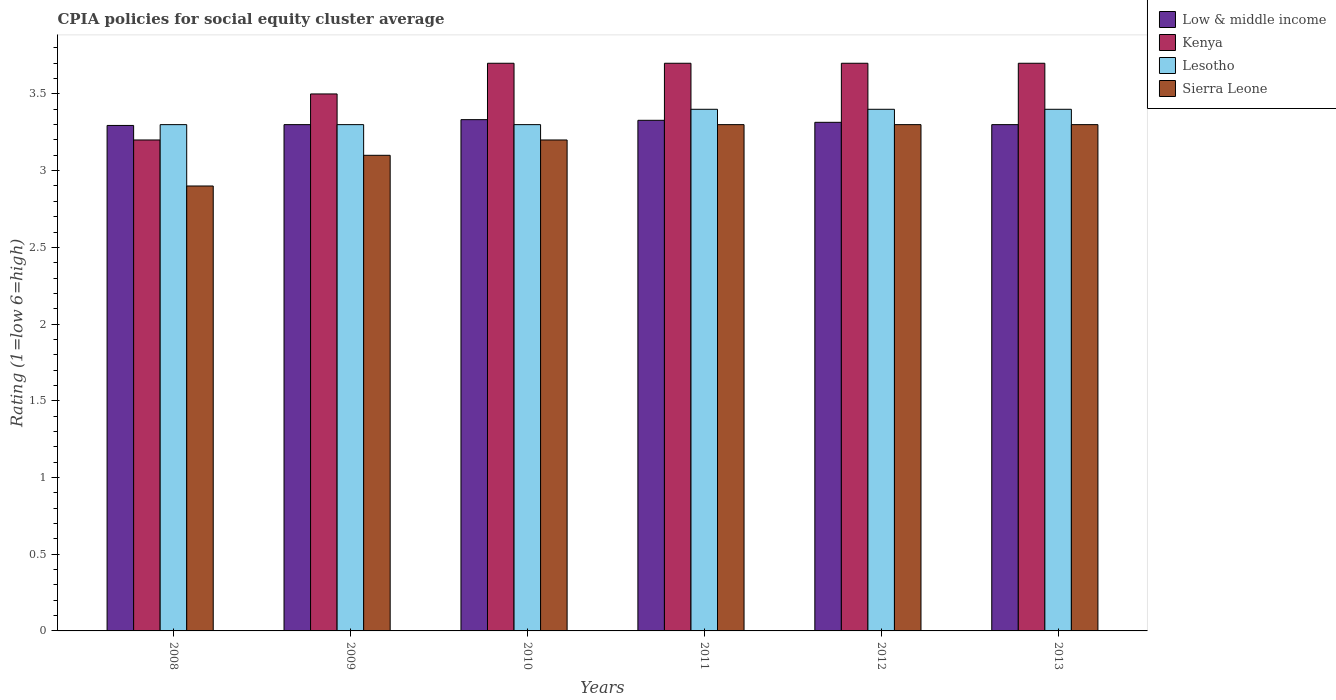How many different coloured bars are there?
Your answer should be compact. 4. How many groups of bars are there?
Offer a terse response. 6. Are the number of bars on each tick of the X-axis equal?
Provide a short and direct response. Yes. In how many cases, is the number of bars for a given year not equal to the number of legend labels?
Provide a succinct answer. 0. Across all years, what is the maximum CPIA rating in Lesotho?
Your answer should be very brief. 3.4. What is the total CPIA rating in Sierra Leone in the graph?
Your answer should be very brief. 19.1. What is the difference between the CPIA rating in Low & middle income in 2011 and that in 2012?
Offer a terse response. 0.01. What is the difference between the CPIA rating in Sierra Leone in 2009 and the CPIA rating in Kenya in 2013?
Your answer should be compact. -0.6. What is the average CPIA rating in Low & middle income per year?
Give a very brief answer. 3.31. In the year 2008, what is the difference between the CPIA rating in Lesotho and CPIA rating in Kenya?
Give a very brief answer. 0.1. What is the ratio of the CPIA rating in Sierra Leone in 2009 to that in 2011?
Your response must be concise. 0.94. Is the CPIA rating in Lesotho in 2011 less than that in 2013?
Offer a terse response. No. What is the difference between the highest and the second highest CPIA rating in Lesotho?
Your response must be concise. 0. What is the difference between the highest and the lowest CPIA rating in Low & middle income?
Give a very brief answer. 0.04. In how many years, is the CPIA rating in Sierra Leone greater than the average CPIA rating in Sierra Leone taken over all years?
Your answer should be very brief. 4. Is the sum of the CPIA rating in Low & middle income in 2009 and 2011 greater than the maximum CPIA rating in Kenya across all years?
Give a very brief answer. Yes. What does the 4th bar from the right in 2012 represents?
Give a very brief answer. Low & middle income. Is it the case that in every year, the sum of the CPIA rating in Kenya and CPIA rating in Low & middle income is greater than the CPIA rating in Lesotho?
Give a very brief answer. Yes. How many bars are there?
Give a very brief answer. 24. Are all the bars in the graph horizontal?
Your answer should be compact. No. Are the values on the major ticks of Y-axis written in scientific E-notation?
Your answer should be compact. No. Does the graph contain any zero values?
Ensure brevity in your answer.  No. Where does the legend appear in the graph?
Offer a very short reply. Top right. How many legend labels are there?
Keep it short and to the point. 4. How are the legend labels stacked?
Provide a succinct answer. Vertical. What is the title of the graph?
Keep it short and to the point. CPIA policies for social equity cluster average. Does "Serbia" appear as one of the legend labels in the graph?
Keep it short and to the point. No. What is the label or title of the X-axis?
Your answer should be very brief. Years. What is the Rating (1=low 6=high) of Low & middle income in 2008?
Give a very brief answer. 3.29. What is the Rating (1=low 6=high) in Kenya in 2008?
Provide a short and direct response. 3.2. What is the Rating (1=low 6=high) in Low & middle income in 2009?
Your response must be concise. 3.3. What is the Rating (1=low 6=high) in Sierra Leone in 2009?
Your answer should be compact. 3.1. What is the Rating (1=low 6=high) of Low & middle income in 2010?
Give a very brief answer. 3.33. What is the Rating (1=low 6=high) in Kenya in 2010?
Offer a terse response. 3.7. What is the Rating (1=low 6=high) of Lesotho in 2010?
Offer a very short reply. 3.3. What is the Rating (1=low 6=high) in Low & middle income in 2011?
Provide a succinct answer. 3.33. What is the Rating (1=low 6=high) in Kenya in 2011?
Give a very brief answer. 3.7. What is the Rating (1=low 6=high) in Low & middle income in 2012?
Offer a terse response. 3.31. What is the Rating (1=low 6=high) in Sierra Leone in 2012?
Keep it short and to the point. 3.3. What is the Rating (1=low 6=high) in Low & middle income in 2013?
Give a very brief answer. 3.3. What is the Rating (1=low 6=high) in Kenya in 2013?
Offer a very short reply. 3.7. Across all years, what is the maximum Rating (1=low 6=high) in Low & middle income?
Make the answer very short. 3.33. Across all years, what is the maximum Rating (1=low 6=high) of Kenya?
Give a very brief answer. 3.7. Across all years, what is the minimum Rating (1=low 6=high) of Low & middle income?
Your answer should be compact. 3.29. Across all years, what is the minimum Rating (1=low 6=high) of Kenya?
Give a very brief answer. 3.2. Across all years, what is the minimum Rating (1=low 6=high) of Lesotho?
Your answer should be compact. 3.3. Across all years, what is the minimum Rating (1=low 6=high) in Sierra Leone?
Offer a terse response. 2.9. What is the total Rating (1=low 6=high) in Low & middle income in the graph?
Offer a very short reply. 19.87. What is the total Rating (1=low 6=high) of Kenya in the graph?
Your answer should be compact. 21.5. What is the total Rating (1=low 6=high) in Lesotho in the graph?
Your answer should be very brief. 20.1. What is the total Rating (1=low 6=high) of Sierra Leone in the graph?
Provide a short and direct response. 19.1. What is the difference between the Rating (1=low 6=high) of Low & middle income in 2008 and that in 2009?
Ensure brevity in your answer.  -0.01. What is the difference between the Rating (1=low 6=high) of Low & middle income in 2008 and that in 2010?
Ensure brevity in your answer.  -0.04. What is the difference between the Rating (1=low 6=high) of Lesotho in 2008 and that in 2010?
Make the answer very short. 0. What is the difference between the Rating (1=low 6=high) of Low & middle income in 2008 and that in 2011?
Your response must be concise. -0.03. What is the difference between the Rating (1=low 6=high) in Lesotho in 2008 and that in 2011?
Your answer should be very brief. -0.1. What is the difference between the Rating (1=low 6=high) of Low & middle income in 2008 and that in 2012?
Ensure brevity in your answer.  -0.02. What is the difference between the Rating (1=low 6=high) of Low & middle income in 2008 and that in 2013?
Provide a short and direct response. -0.01. What is the difference between the Rating (1=low 6=high) of Kenya in 2008 and that in 2013?
Provide a short and direct response. -0.5. What is the difference between the Rating (1=low 6=high) of Low & middle income in 2009 and that in 2010?
Your answer should be very brief. -0.03. What is the difference between the Rating (1=low 6=high) of Low & middle income in 2009 and that in 2011?
Provide a short and direct response. -0.03. What is the difference between the Rating (1=low 6=high) of Kenya in 2009 and that in 2011?
Provide a short and direct response. -0.2. What is the difference between the Rating (1=low 6=high) in Lesotho in 2009 and that in 2011?
Make the answer very short. -0.1. What is the difference between the Rating (1=low 6=high) in Sierra Leone in 2009 and that in 2011?
Keep it short and to the point. -0.2. What is the difference between the Rating (1=low 6=high) in Low & middle income in 2009 and that in 2012?
Keep it short and to the point. -0.01. What is the difference between the Rating (1=low 6=high) in Kenya in 2009 and that in 2012?
Your answer should be compact. -0.2. What is the difference between the Rating (1=low 6=high) of Low & middle income in 2009 and that in 2013?
Keep it short and to the point. 0. What is the difference between the Rating (1=low 6=high) of Kenya in 2009 and that in 2013?
Provide a short and direct response. -0.2. What is the difference between the Rating (1=low 6=high) of Low & middle income in 2010 and that in 2011?
Ensure brevity in your answer.  0. What is the difference between the Rating (1=low 6=high) in Lesotho in 2010 and that in 2011?
Provide a short and direct response. -0.1. What is the difference between the Rating (1=low 6=high) of Low & middle income in 2010 and that in 2012?
Provide a succinct answer. 0.02. What is the difference between the Rating (1=low 6=high) of Kenya in 2010 and that in 2012?
Give a very brief answer. 0. What is the difference between the Rating (1=low 6=high) in Lesotho in 2010 and that in 2012?
Provide a short and direct response. -0.1. What is the difference between the Rating (1=low 6=high) in Sierra Leone in 2010 and that in 2012?
Provide a succinct answer. -0.1. What is the difference between the Rating (1=low 6=high) in Low & middle income in 2010 and that in 2013?
Provide a short and direct response. 0.03. What is the difference between the Rating (1=low 6=high) in Kenya in 2010 and that in 2013?
Your answer should be very brief. 0. What is the difference between the Rating (1=low 6=high) in Sierra Leone in 2010 and that in 2013?
Offer a very short reply. -0.1. What is the difference between the Rating (1=low 6=high) of Low & middle income in 2011 and that in 2012?
Your answer should be very brief. 0.01. What is the difference between the Rating (1=low 6=high) of Sierra Leone in 2011 and that in 2012?
Your answer should be compact. 0. What is the difference between the Rating (1=low 6=high) of Low & middle income in 2011 and that in 2013?
Provide a succinct answer. 0.03. What is the difference between the Rating (1=low 6=high) of Kenya in 2011 and that in 2013?
Offer a very short reply. 0. What is the difference between the Rating (1=low 6=high) of Low & middle income in 2012 and that in 2013?
Your response must be concise. 0.01. What is the difference between the Rating (1=low 6=high) in Kenya in 2012 and that in 2013?
Give a very brief answer. 0. What is the difference between the Rating (1=low 6=high) of Lesotho in 2012 and that in 2013?
Your answer should be compact. 0. What is the difference between the Rating (1=low 6=high) in Sierra Leone in 2012 and that in 2013?
Keep it short and to the point. 0. What is the difference between the Rating (1=low 6=high) in Low & middle income in 2008 and the Rating (1=low 6=high) in Kenya in 2009?
Make the answer very short. -0.21. What is the difference between the Rating (1=low 6=high) in Low & middle income in 2008 and the Rating (1=low 6=high) in Lesotho in 2009?
Your answer should be compact. -0.01. What is the difference between the Rating (1=low 6=high) of Low & middle income in 2008 and the Rating (1=low 6=high) of Sierra Leone in 2009?
Keep it short and to the point. 0.19. What is the difference between the Rating (1=low 6=high) of Lesotho in 2008 and the Rating (1=low 6=high) of Sierra Leone in 2009?
Give a very brief answer. 0.2. What is the difference between the Rating (1=low 6=high) in Low & middle income in 2008 and the Rating (1=low 6=high) in Kenya in 2010?
Give a very brief answer. -0.41. What is the difference between the Rating (1=low 6=high) in Low & middle income in 2008 and the Rating (1=low 6=high) in Lesotho in 2010?
Your answer should be very brief. -0.01. What is the difference between the Rating (1=low 6=high) in Low & middle income in 2008 and the Rating (1=low 6=high) in Sierra Leone in 2010?
Your answer should be very brief. 0.09. What is the difference between the Rating (1=low 6=high) in Low & middle income in 2008 and the Rating (1=low 6=high) in Kenya in 2011?
Provide a succinct answer. -0.41. What is the difference between the Rating (1=low 6=high) of Low & middle income in 2008 and the Rating (1=low 6=high) of Lesotho in 2011?
Keep it short and to the point. -0.11. What is the difference between the Rating (1=low 6=high) in Low & middle income in 2008 and the Rating (1=low 6=high) in Sierra Leone in 2011?
Give a very brief answer. -0.01. What is the difference between the Rating (1=low 6=high) of Low & middle income in 2008 and the Rating (1=low 6=high) of Kenya in 2012?
Give a very brief answer. -0.41. What is the difference between the Rating (1=low 6=high) in Low & middle income in 2008 and the Rating (1=low 6=high) in Lesotho in 2012?
Ensure brevity in your answer.  -0.11. What is the difference between the Rating (1=low 6=high) in Low & middle income in 2008 and the Rating (1=low 6=high) in Sierra Leone in 2012?
Offer a terse response. -0.01. What is the difference between the Rating (1=low 6=high) in Kenya in 2008 and the Rating (1=low 6=high) in Lesotho in 2012?
Offer a very short reply. -0.2. What is the difference between the Rating (1=low 6=high) in Low & middle income in 2008 and the Rating (1=low 6=high) in Kenya in 2013?
Your answer should be very brief. -0.41. What is the difference between the Rating (1=low 6=high) in Low & middle income in 2008 and the Rating (1=low 6=high) in Lesotho in 2013?
Provide a short and direct response. -0.11. What is the difference between the Rating (1=low 6=high) in Low & middle income in 2008 and the Rating (1=low 6=high) in Sierra Leone in 2013?
Keep it short and to the point. -0.01. What is the difference between the Rating (1=low 6=high) of Kenya in 2008 and the Rating (1=low 6=high) of Lesotho in 2013?
Provide a succinct answer. -0.2. What is the difference between the Rating (1=low 6=high) of Low & middle income in 2009 and the Rating (1=low 6=high) of Kenya in 2010?
Give a very brief answer. -0.4. What is the difference between the Rating (1=low 6=high) of Low & middle income in 2009 and the Rating (1=low 6=high) of Sierra Leone in 2010?
Offer a very short reply. 0.1. What is the difference between the Rating (1=low 6=high) in Kenya in 2009 and the Rating (1=low 6=high) in Sierra Leone in 2010?
Your answer should be compact. 0.3. What is the difference between the Rating (1=low 6=high) in Low & middle income in 2009 and the Rating (1=low 6=high) in Lesotho in 2011?
Give a very brief answer. -0.1. What is the difference between the Rating (1=low 6=high) of Low & middle income in 2009 and the Rating (1=low 6=high) of Sierra Leone in 2011?
Offer a very short reply. 0. What is the difference between the Rating (1=low 6=high) in Kenya in 2009 and the Rating (1=low 6=high) in Lesotho in 2011?
Offer a very short reply. 0.1. What is the difference between the Rating (1=low 6=high) in Lesotho in 2009 and the Rating (1=low 6=high) in Sierra Leone in 2011?
Make the answer very short. 0. What is the difference between the Rating (1=low 6=high) in Low & middle income in 2009 and the Rating (1=low 6=high) in Kenya in 2012?
Provide a short and direct response. -0.4. What is the difference between the Rating (1=low 6=high) of Kenya in 2009 and the Rating (1=low 6=high) of Lesotho in 2012?
Provide a succinct answer. 0.1. What is the difference between the Rating (1=low 6=high) of Lesotho in 2009 and the Rating (1=low 6=high) of Sierra Leone in 2012?
Your answer should be very brief. 0. What is the difference between the Rating (1=low 6=high) in Low & middle income in 2009 and the Rating (1=low 6=high) in Kenya in 2013?
Offer a very short reply. -0.4. What is the difference between the Rating (1=low 6=high) of Low & middle income in 2009 and the Rating (1=low 6=high) of Sierra Leone in 2013?
Offer a terse response. 0. What is the difference between the Rating (1=low 6=high) of Kenya in 2009 and the Rating (1=low 6=high) of Sierra Leone in 2013?
Give a very brief answer. 0.2. What is the difference between the Rating (1=low 6=high) in Low & middle income in 2010 and the Rating (1=low 6=high) in Kenya in 2011?
Make the answer very short. -0.37. What is the difference between the Rating (1=low 6=high) in Low & middle income in 2010 and the Rating (1=low 6=high) in Lesotho in 2011?
Your answer should be very brief. -0.07. What is the difference between the Rating (1=low 6=high) of Low & middle income in 2010 and the Rating (1=low 6=high) of Sierra Leone in 2011?
Keep it short and to the point. 0.03. What is the difference between the Rating (1=low 6=high) in Kenya in 2010 and the Rating (1=low 6=high) in Lesotho in 2011?
Your answer should be very brief. 0.3. What is the difference between the Rating (1=low 6=high) of Kenya in 2010 and the Rating (1=low 6=high) of Sierra Leone in 2011?
Your answer should be compact. 0.4. What is the difference between the Rating (1=low 6=high) of Lesotho in 2010 and the Rating (1=low 6=high) of Sierra Leone in 2011?
Your answer should be very brief. 0. What is the difference between the Rating (1=low 6=high) in Low & middle income in 2010 and the Rating (1=low 6=high) in Kenya in 2012?
Keep it short and to the point. -0.37. What is the difference between the Rating (1=low 6=high) in Low & middle income in 2010 and the Rating (1=low 6=high) in Lesotho in 2012?
Your answer should be compact. -0.07. What is the difference between the Rating (1=low 6=high) in Low & middle income in 2010 and the Rating (1=low 6=high) in Sierra Leone in 2012?
Give a very brief answer. 0.03. What is the difference between the Rating (1=low 6=high) of Kenya in 2010 and the Rating (1=low 6=high) of Sierra Leone in 2012?
Your response must be concise. 0.4. What is the difference between the Rating (1=low 6=high) in Lesotho in 2010 and the Rating (1=low 6=high) in Sierra Leone in 2012?
Your response must be concise. 0. What is the difference between the Rating (1=low 6=high) in Low & middle income in 2010 and the Rating (1=low 6=high) in Kenya in 2013?
Make the answer very short. -0.37. What is the difference between the Rating (1=low 6=high) of Low & middle income in 2010 and the Rating (1=low 6=high) of Lesotho in 2013?
Give a very brief answer. -0.07. What is the difference between the Rating (1=low 6=high) of Low & middle income in 2010 and the Rating (1=low 6=high) of Sierra Leone in 2013?
Your answer should be very brief. 0.03. What is the difference between the Rating (1=low 6=high) of Kenya in 2010 and the Rating (1=low 6=high) of Sierra Leone in 2013?
Your response must be concise. 0.4. What is the difference between the Rating (1=low 6=high) of Lesotho in 2010 and the Rating (1=low 6=high) of Sierra Leone in 2013?
Offer a terse response. 0. What is the difference between the Rating (1=low 6=high) of Low & middle income in 2011 and the Rating (1=low 6=high) of Kenya in 2012?
Your response must be concise. -0.37. What is the difference between the Rating (1=low 6=high) in Low & middle income in 2011 and the Rating (1=low 6=high) in Lesotho in 2012?
Your answer should be compact. -0.07. What is the difference between the Rating (1=low 6=high) of Low & middle income in 2011 and the Rating (1=low 6=high) of Sierra Leone in 2012?
Your response must be concise. 0.03. What is the difference between the Rating (1=low 6=high) in Low & middle income in 2011 and the Rating (1=low 6=high) in Kenya in 2013?
Ensure brevity in your answer.  -0.37. What is the difference between the Rating (1=low 6=high) of Low & middle income in 2011 and the Rating (1=low 6=high) of Lesotho in 2013?
Provide a short and direct response. -0.07. What is the difference between the Rating (1=low 6=high) in Low & middle income in 2011 and the Rating (1=low 6=high) in Sierra Leone in 2013?
Keep it short and to the point. 0.03. What is the difference between the Rating (1=low 6=high) in Kenya in 2011 and the Rating (1=low 6=high) in Sierra Leone in 2013?
Your answer should be very brief. 0.4. What is the difference between the Rating (1=low 6=high) of Low & middle income in 2012 and the Rating (1=low 6=high) of Kenya in 2013?
Make the answer very short. -0.39. What is the difference between the Rating (1=low 6=high) in Low & middle income in 2012 and the Rating (1=low 6=high) in Lesotho in 2013?
Keep it short and to the point. -0.09. What is the difference between the Rating (1=low 6=high) in Low & middle income in 2012 and the Rating (1=low 6=high) in Sierra Leone in 2013?
Your answer should be very brief. 0.01. What is the difference between the Rating (1=low 6=high) of Kenya in 2012 and the Rating (1=low 6=high) of Sierra Leone in 2013?
Your response must be concise. 0.4. What is the difference between the Rating (1=low 6=high) in Lesotho in 2012 and the Rating (1=low 6=high) in Sierra Leone in 2013?
Give a very brief answer. 0.1. What is the average Rating (1=low 6=high) of Low & middle income per year?
Your answer should be compact. 3.31. What is the average Rating (1=low 6=high) of Kenya per year?
Provide a short and direct response. 3.58. What is the average Rating (1=low 6=high) in Lesotho per year?
Offer a very short reply. 3.35. What is the average Rating (1=low 6=high) of Sierra Leone per year?
Your answer should be very brief. 3.18. In the year 2008, what is the difference between the Rating (1=low 6=high) of Low & middle income and Rating (1=low 6=high) of Kenya?
Your answer should be compact. 0.09. In the year 2008, what is the difference between the Rating (1=low 6=high) of Low & middle income and Rating (1=low 6=high) of Lesotho?
Make the answer very short. -0.01. In the year 2008, what is the difference between the Rating (1=low 6=high) of Low & middle income and Rating (1=low 6=high) of Sierra Leone?
Your response must be concise. 0.39. In the year 2008, what is the difference between the Rating (1=low 6=high) of Kenya and Rating (1=low 6=high) of Sierra Leone?
Offer a terse response. 0.3. In the year 2009, what is the difference between the Rating (1=low 6=high) of Low & middle income and Rating (1=low 6=high) of Kenya?
Provide a succinct answer. -0.2. In the year 2009, what is the difference between the Rating (1=low 6=high) of Low & middle income and Rating (1=low 6=high) of Lesotho?
Ensure brevity in your answer.  0. In the year 2009, what is the difference between the Rating (1=low 6=high) in Low & middle income and Rating (1=low 6=high) in Sierra Leone?
Your answer should be very brief. 0.2. In the year 2009, what is the difference between the Rating (1=low 6=high) in Kenya and Rating (1=low 6=high) in Lesotho?
Provide a short and direct response. 0.2. In the year 2009, what is the difference between the Rating (1=low 6=high) in Kenya and Rating (1=low 6=high) in Sierra Leone?
Provide a succinct answer. 0.4. In the year 2009, what is the difference between the Rating (1=low 6=high) of Lesotho and Rating (1=low 6=high) of Sierra Leone?
Keep it short and to the point. 0.2. In the year 2010, what is the difference between the Rating (1=low 6=high) of Low & middle income and Rating (1=low 6=high) of Kenya?
Ensure brevity in your answer.  -0.37. In the year 2010, what is the difference between the Rating (1=low 6=high) of Low & middle income and Rating (1=low 6=high) of Lesotho?
Give a very brief answer. 0.03. In the year 2010, what is the difference between the Rating (1=low 6=high) in Low & middle income and Rating (1=low 6=high) in Sierra Leone?
Provide a succinct answer. 0.13. In the year 2010, what is the difference between the Rating (1=low 6=high) of Kenya and Rating (1=low 6=high) of Lesotho?
Provide a short and direct response. 0.4. In the year 2011, what is the difference between the Rating (1=low 6=high) of Low & middle income and Rating (1=low 6=high) of Kenya?
Provide a short and direct response. -0.37. In the year 2011, what is the difference between the Rating (1=low 6=high) in Low & middle income and Rating (1=low 6=high) in Lesotho?
Ensure brevity in your answer.  -0.07. In the year 2011, what is the difference between the Rating (1=low 6=high) of Low & middle income and Rating (1=low 6=high) of Sierra Leone?
Offer a very short reply. 0.03. In the year 2012, what is the difference between the Rating (1=low 6=high) of Low & middle income and Rating (1=low 6=high) of Kenya?
Make the answer very short. -0.39. In the year 2012, what is the difference between the Rating (1=low 6=high) in Low & middle income and Rating (1=low 6=high) in Lesotho?
Give a very brief answer. -0.09. In the year 2012, what is the difference between the Rating (1=low 6=high) in Low & middle income and Rating (1=low 6=high) in Sierra Leone?
Keep it short and to the point. 0.01. In the year 2012, what is the difference between the Rating (1=low 6=high) of Lesotho and Rating (1=low 6=high) of Sierra Leone?
Your response must be concise. 0.1. In the year 2013, what is the difference between the Rating (1=low 6=high) in Low & middle income and Rating (1=low 6=high) in Lesotho?
Offer a terse response. -0.1. In the year 2013, what is the difference between the Rating (1=low 6=high) in Kenya and Rating (1=low 6=high) in Lesotho?
Provide a short and direct response. 0.3. What is the ratio of the Rating (1=low 6=high) of Low & middle income in 2008 to that in 2009?
Your answer should be compact. 1. What is the ratio of the Rating (1=low 6=high) in Kenya in 2008 to that in 2009?
Ensure brevity in your answer.  0.91. What is the ratio of the Rating (1=low 6=high) in Sierra Leone in 2008 to that in 2009?
Ensure brevity in your answer.  0.94. What is the ratio of the Rating (1=low 6=high) in Low & middle income in 2008 to that in 2010?
Keep it short and to the point. 0.99. What is the ratio of the Rating (1=low 6=high) in Kenya in 2008 to that in 2010?
Offer a terse response. 0.86. What is the ratio of the Rating (1=low 6=high) of Sierra Leone in 2008 to that in 2010?
Your answer should be compact. 0.91. What is the ratio of the Rating (1=low 6=high) of Kenya in 2008 to that in 2011?
Provide a succinct answer. 0.86. What is the ratio of the Rating (1=low 6=high) in Lesotho in 2008 to that in 2011?
Offer a terse response. 0.97. What is the ratio of the Rating (1=low 6=high) in Sierra Leone in 2008 to that in 2011?
Your response must be concise. 0.88. What is the ratio of the Rating (1=low 6=high) of Low & middle income in 2008 to that in 2012?
Make the answer very short. 0.99. What is the ratio of the Rating (1=low 6=high) of Kenya in 2008 to that in 2012?
Offer a terse response. 0.86. What is the ratio of the Rating (1=low 6=high) of Lesotho in 2008 to that in 2012?
Your response must be concise. 0.97. What is the ratio of the Rating (1=low 6=high) in Sierra Leone in 2008 to that in 2012?
Keep it short and to the point. 0.88. What is the ratio of the Rating (1=low 6=high) in Kenya in 2008 to that in 2013?
Ensure brevity in your answer.  0.86. What is the ratio of the Rating (1=low 6=high) in Lesotho in 2008 to that in 2013?
Provide a short and direct response. 0.97. What is the ratio of the Rating (1=low 6=high) in Sierra Leone in 2008 to that in 2013?
Your answer should be very brief. 0.88. What is the ratio of the Rating (1=low 6=high) in Low & middle income in 2009 to that in 2010?
Your response must be concise. 0.99. What is the ratio of the Rating (1=low 6=high) of Kenya in 2009 to that in 2010?
Your response must be concise. 0.95. What is the ratio of the Rating (1=low 6=high) in Sierra Leone in 2009 to that in 2010?
Offer a terse response. 0.97. What is the ratio of the Rating (1=low 6=high) of Low & middle income in 2009 to that in 2011?
Provide a succinct answer. 0.99. What is the ratio of the Rating (1=low 6=high) of Kenya in 2009 to that in 2011?
Give a very brief answer. 0.95. What is the ratio of the Rating (1=low 6=high) of Lesotho in 2009 to that in 2011?
Keep it short and to the point. 0.97. What is the ratio of the Rating (1=low 6=high) in Sierra Leone in 2009 to that in 2011?
Your answer should be compact. 0.94. What is the ratio of the Rating (1=low 6=high) in Low & middle income in 2009 to that in 2012?
Ensure brevity in your answer.  1. What is the ratio of the Rating (1=low 6=high) in Kenya in 2009 to that in 2012?
Your response must be concise. 0.95. What is the ratio of the Rating (1=low 6=high) of Lesotho in 2009 to that in 2012?
Ensure brevity in your answer.  0.97. What is the ratio of the Rating (1=low 6=high) in Sierra Leone in 2009 to that in 2012?
Make the answer very short. 0.94. What is the ratio of the Rating (1=low 6=high) in Kenya in 2009 to that in 2013?
Make the answer very short. 0.95. What is the ratio of the Rating (1=low 6=high) of Lesotho in 2009 to that in 2013?
Ensure brevity in your answer.  0.97. What is the ratio of the Rating (1=low 6=high) of Sierra Leone in 2009 to that in 2013?
Your answer should be compact. 0.94. What is the ratio of the Rating (1=low 6=high) in Lesotho in 2010 to that in 2011?
Your answer should be compact. 0.97. What is the ratio of the Rating (1=low 6=high) in Sierra Leone in 2010 to that in 2011?
Make the answer very short. 0.97. What is the ratio of the Rating (1=low 6=high) of Low & middle income in 2010 to that in 2012?
Your answer should be very brief. 1.01. What is the ratio of the Rating (1=low 6=high) of Lesotho in 2010 to that in 2012?
Your answer should be very brief. 0.97. What is the ratio of the Rating (1=low 6=high) of Sierra Leone in 2010 to that in 2012?
Give a very brief answer. 0.97. What is the ratio of the Rating (1=low 6=high) of Low & middle income in 2010 to that in 2013?
Provide a succinct answer. 1.01. What is the ratio of the Rating (1=low 6=high) in Kenya in 2010 to that in 2013?
Keep it short and to the point. 1. What is the ratio of the Rating (1=low 6=high) of Lesotho in 2010 to that in 2013?
Make the answer very short. 0.97. What is the ratio of the Rating (1=low 6=high) of Sierra Leone in 2010 to that in 2013?
Ensure brevity in your answer.  0.97. What is the ratio of the Rating (1=low 6=high) of Low & middle income in 2011 to that in 2012?
Make the answer very short. 1. What is the ratio of the Rating (1=low 6=high) in Kenya in 2011 to that in 2012?
Your answer should be very brief. 1. What is the ratio of the Rating (1=low 6=high) of Lesotho in 2011 to that in 2012?
Offer a terse response. 1. What is the ratio of the Rating (1=low 6=high) in Sierra Leone in 2011 to that in 2012?
Your answer should be very brief. 1. What is the ratio of the Rating (1=low 6=high) in Low & middle income in 2011 to that in 2013?
Give a very brief answer. 1.01. What is the ratio of the Rating (1=low 6=high) of Kenya in 2011 to that in 2013?
Provide a succinct answer. 1. What is the ratio of the Rating (1=low 6=high) in Low & middle income in 2012 to that in 2013?
Give a very brief answer. 1. What is the ratio of the Rating (1=low 6=high) in Kenya in 2012 to that in 2013?
Offer a very short reply. 1. What is the difference between the highest and the second highest Rating (1=low 6=high) in Low & middle income?
Give a very brief answer. 0. What is the difference between the highest and the lowest Rating (1=low 6=high) in Low & middle income?
Your answer should be compact. 0.04. What is the difference between the highest and the lowest Rating (1=low 6=high) of Kenya?
Your answer should be compact. 0.5. What is the difference between the highest and the lowest Rating (1=low 6=high) of Sierra Leone?
Keep it short and to the point. 0.4. 